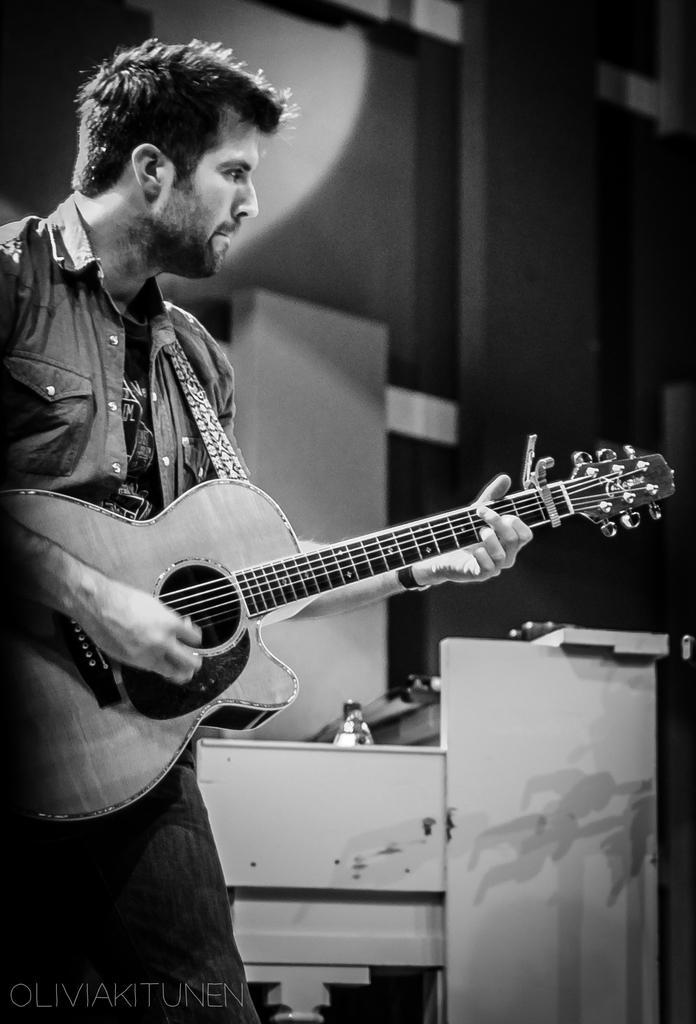Can you describe this image briefly? In this picture in the left side there is a man standing and holding a music instrument which is in yellow color, In the background there is a white color desk and there is a black color wall. 